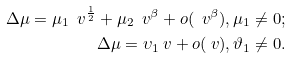Convert formula to latex. <formula><loc_0><loc_0><loc_500><loc_500>\Delta \mu = \mu _ { 1 } \ v ^ { \frac { 1 } { 2 } } + \mu _ { 2 } \ v ^ { \beta } + o ( \ v ^ { \beta } ) , \mu _ { 1 } \ne 0 ; \\ \Delta \mu = \upsilon _ { 1 } \ v + o ( \ v ) , \vartheta _ { 1 } \ne 0 .</formula> 